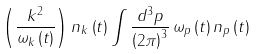Convert formula to latex. <formula><loc_0><loc_0><loc_500><loc_500>\left ( \frac { k ^ { 2 } } { \omega _ { k } \left ( t \right ) } \right ) n _ { k } \left ( t \right ) \int \frac { d ^ { 3 } p } { \left ( 2 \pi \right ) ^ { 3 } } \, \omega _ { p } \left ( t \right ) n _ { p } \left ( t \right )</formula> 